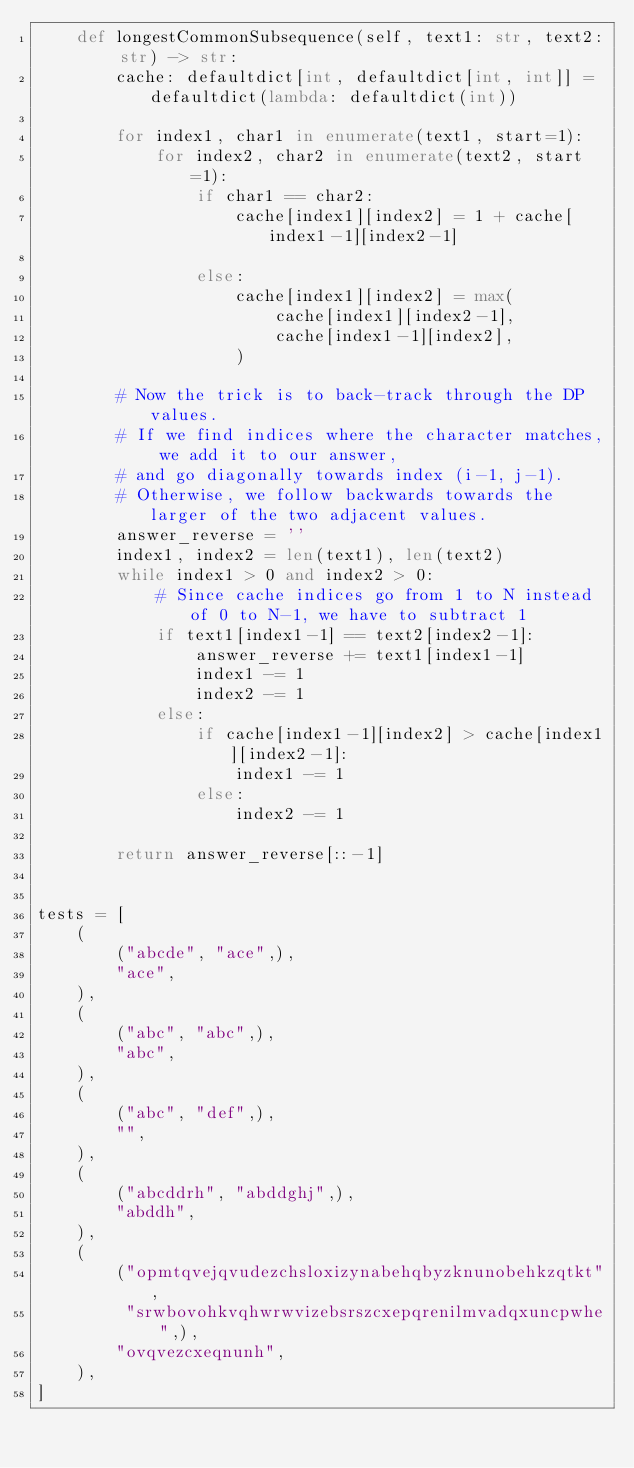<code> <loc_0><loc_0><loc_500><loc_500><_Python_>    def longestCommonSubsequence(self, text1: str, text2: str) -> str:
        cache: defaultdict[int, defaultdict[int, int]] = defaultdict(lambda: defaultdict(int))

        for index1, char1 in enumerate(text1, start=1):
            for index2, char2 in enumerate(text2, start=1):
                if char1 == char2:
                    cache[index1][index2] = 1 + cache[index1-1][index2-1]

                else:
                    cache[index1][index2] = max(
                        cache[index1][index2-1],
                        cache[index1-1][index2],
                    )

        # Now the trick is to back-track through the DP values.
        # If we find indices where the character matches, we add it to our answer,
        # and go diagonally towards index (i-1, j-1).
        # Otherwise, we follow backwards towards the larger of the two adjacent values.
        answer_reverse = ''
        index1, index2 = len(text1), len(text2)
        while index1 > 0 and index2 > 0:
            # Since cache indices go from 1 to N instead of 0 to N-1, we have to subtract 1
            if text1[index1-1] == text2[index2-1]:
                answer_reverse += text1[index1-1]
                index1 -= 1
                index2 -= 1
            else:
                if cache[index1-1][index2] > cache[index1][index2-1]:
                    index1 -= 1
                else:
                    index2 -= 1

        return answer_reverse[::-1]


tests = [
    (
        ("abcde", "ace",),
        "ace",
    ),
    (
        ("abc", "abc",),
        "abc",
    ),
    (
        ("abc", "def",),
        "",
    ),
    (
        ("abcddrh", "abddghj",),
        "abddh",
    ),
    (
        ("opmtqvejqvudezchsloxizynabehqbyzknunobehkzqtkt",
         "srwbovohkvqhwrwvizebsrszcxepqrenilmvadqxuncpwhe",),
        "ovqvezcxeqnunh",
    ),
]
</code> 